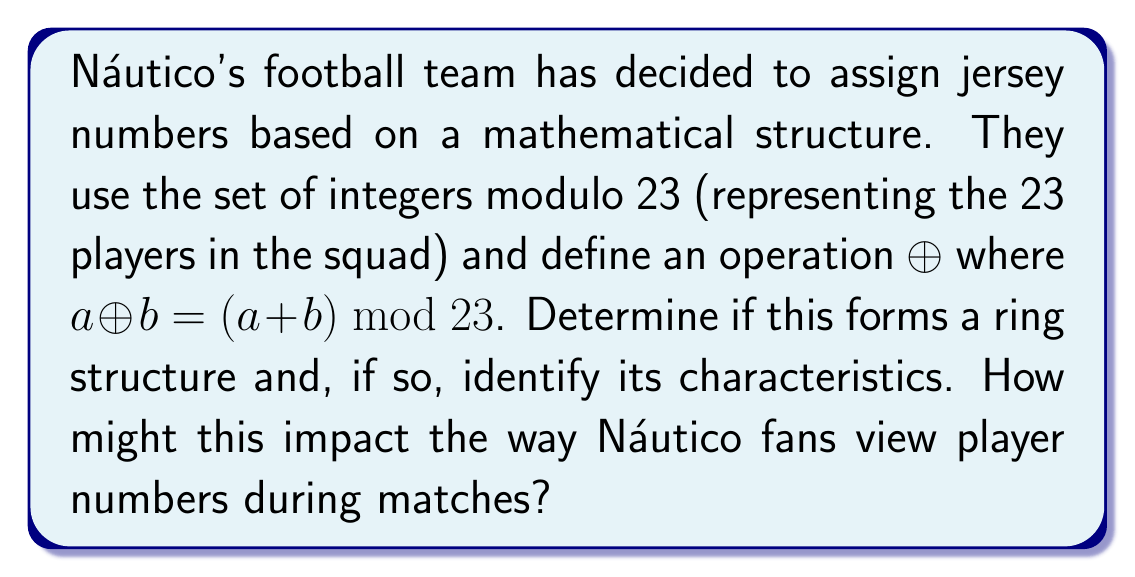What is the answer to this math problem? To determine if this forms a ring structure, we need to check if it satisfies the properties of a ring:

1. Closure under addition: 
For any $a, b \in \mathbb{Z}_{23}$, $a \oplus b = (a + b) \bmod 23$ is always in $\mathbb{Z}_{23}$.

2. Associativity of addition:
For any $a, b, c \in \mathbb{Z}_{23}$:
$$(a \oplus b) \oplus c = ((a + b) \bmod 23 + c) \bmod 23 = (a + b + c) \bmod 23$$
$$a \oplus (b \oplus c) = (a + (b + c) \bmod 23) \bmod 23 = (a + b + c) \bmod 23$$

3. Commutativity of addition:
For any $a, b \in \mathbb{Z}_{23}$:
$$a \oplus b = (a + b) \bmod 23 = (b + a) \bmod 23 = b \oplus a$$

4. Additive identity:
The element 0 serves as the additive identity since $a \oplus 0 = 0 \oplus a = a$ for all $a \in \mathbb{Z}_{23}$.

5. Additive inverse:
For each $a \in \mathbb{Z}_{23}$, there exists an element $-a \bmod 23$ such that $a \oplus (-a \bmod 23) = 0$.

6. Closure under multiplication:
Define multiplication as $(a \cdot b) \bmod 23$. This operation is closed in $\mathbb{Z}_{23}$.

7. Associativity of multiplication:
For any $a, b, c \in \mathbb{Z}_{23}$:
$$(a \cdot b) \cdot c \bmod 23 = a \cdot (b \cdot c) \bmod 23$$

8. Distributivity:
For any $a, b, c \in \mathbb{Z}_{23}$:
$$a \cdot (b \oplus c) \bmod 23 = (a \cdot b \oplus a \cdot c) \bmod 23$$

Since all these properties are satisfied, $(\mathbb{Z}_{23}, \oplus, \cdot)$ forms a ring.

Characteristics of this ring:
- It is a finite ring with 23 elements.
- It is a commutative ring (both addition and multiplication are commutative).
- It has no zero divisors (as 23 is prime).
- It is a field, as every non-zero element has a multiplicative inverse.

For Náutico fans, this structure means that player numbers have interesting mathematical properties. For example, adding two player numbers and taking the result modulo 23 always gives another valid player number. This could lead to interesting discussions and observations during matches, such as noticing patterns in player number combinations on the field.
Answer: Yes, $(\mathbb{Z}_{23}, \oplus, \cdot)$ forms a ring structure. It is a finite commutative ring with 23 elements, no zero divisors, and is also a field. 